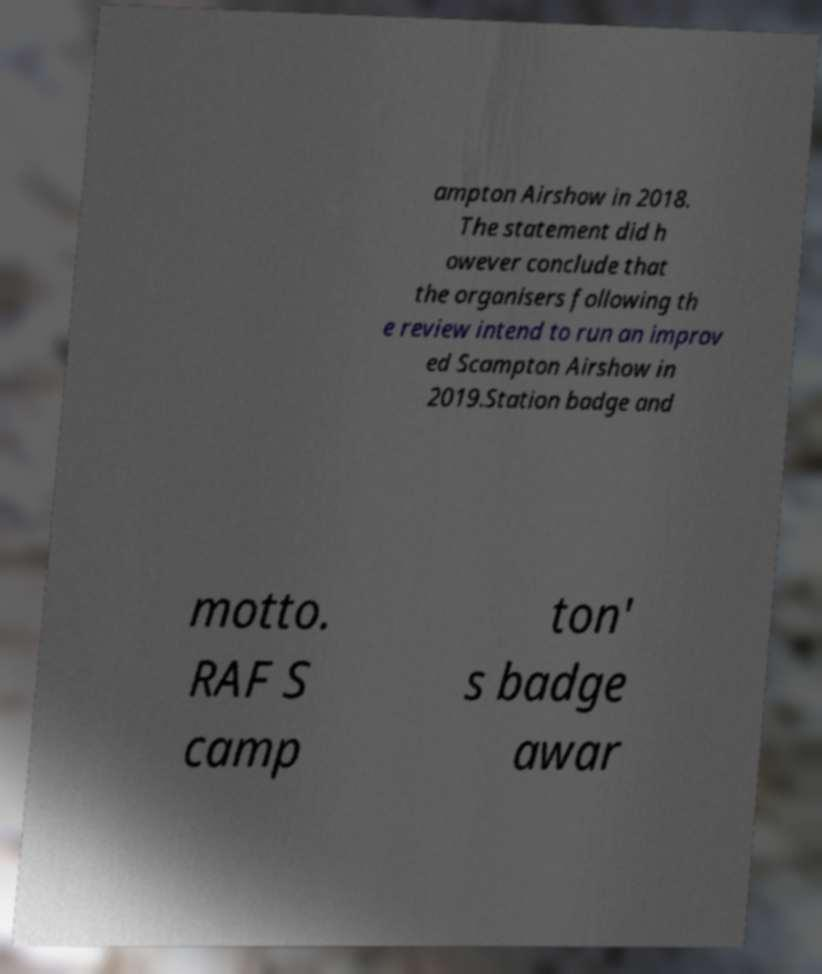Could you assist in decoding the text presented in this image and type it out clearly? ampton Airshow in 2018. The statement did h owever conclude that the organisers following th e review intend to run an improv ed Scampton Airshow in 2019.Station badge and motto. RAF S camp ton' s badge awar 